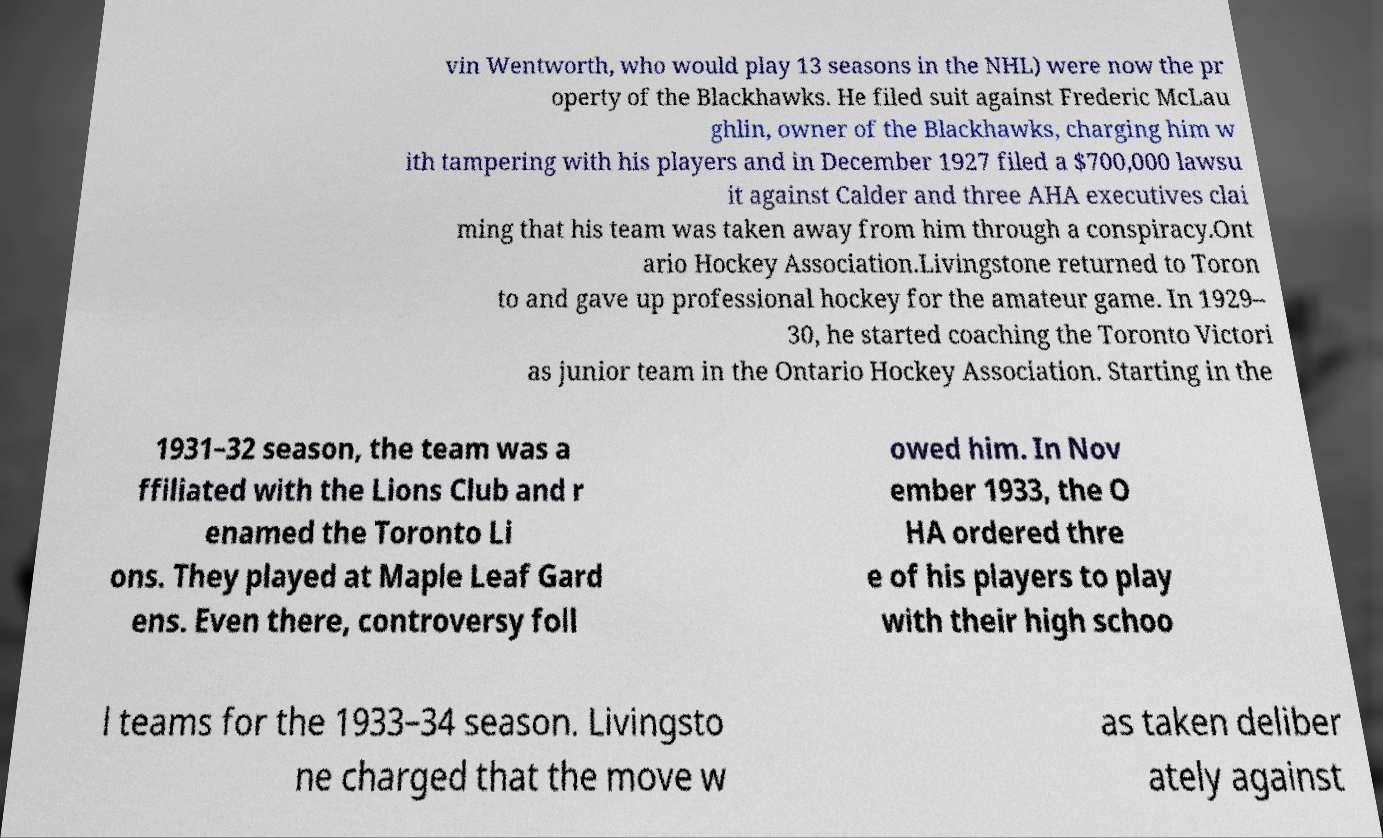What messages or text are displayed in this image? I need them in a readable, typed format. vin Wentworth, who would play 13 seasons in the NHL) were now the pr operty of the Blackhawks. He filed suit against Frederic McLau ghlin, owner of the Blackhawks, charging him w ith tampering with his players and in December 1927 filed a $700,000 lawsu it against Calder and three AHA executives clai ming that his team was taken away from him through a conspiracy.Ont ario Hockey Association.Livingstone returned to Toron to and gave up professional hockey for the amateur game. In 1929– 30, he started coaching the Toronto Victori as junior team in the Ontario Hockey Association. Starting in the 1931–32 season, the team was a ffiliated with the Lions Club and r enamed the Toronto Li ons. They played at Maple Leaf Gard ens. Even there, controversy foll owed him. In Nov ember 1933, the O HA ordered thre e of his players to play with their high schoo l teams for the 1933–34 season. Livingsto ne charged that the move w as taken deliber ately against 